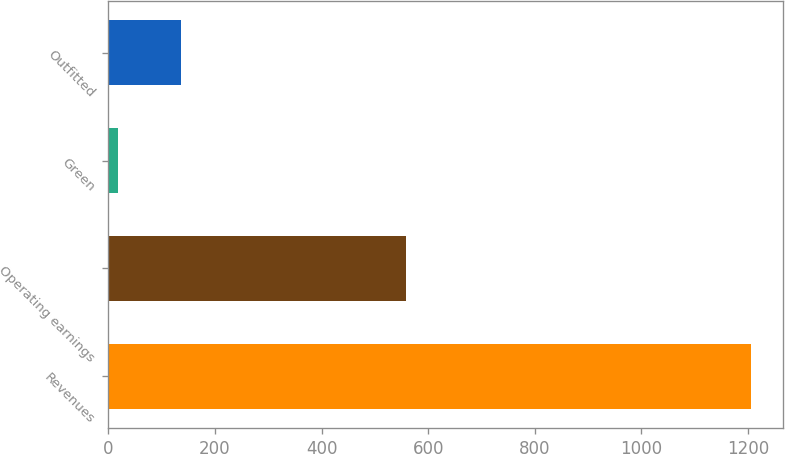<chart> <loc_0><loc_0><loc_500><loc_500><bar_chart><fcel>Revenues<fcel>Operating earnings<fcel>Green<fcel>Outfitted<nl><fcel>1206<fcel>558<fcel>18<fcel>136.8<nl></chart> 